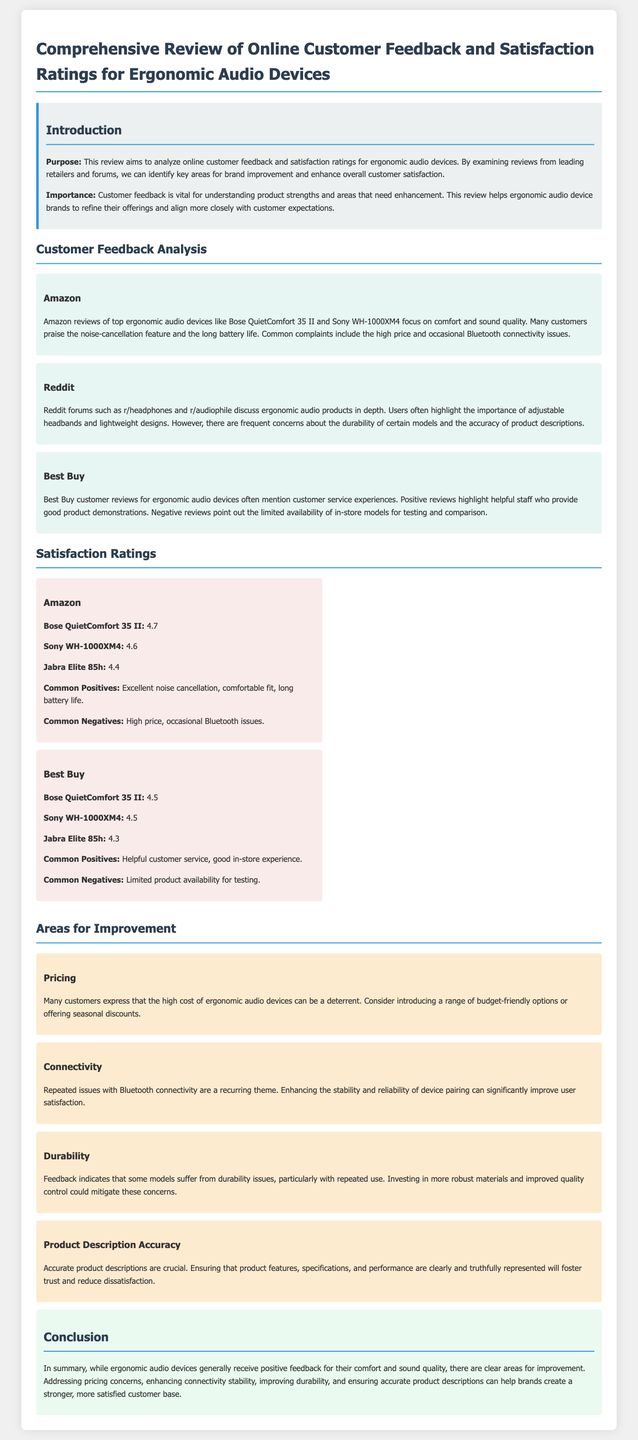What is the purpose of the review? The purpose is to analyze online customer feedback and satisfaction ratings for ergonomic audio devices.
Answer: Analyze online customer feedback and satisfaction ratings What product has the highest rating on Amazon? The product with the highest rating on Amazon is the Bose QuietComfort 35 II, with a rating of 4.7.
Answer: Bose QuietComfort 35 II Which ergonomic audio devices received a 4.5 rating on Best Buy? Both the Bose QuietComfort 35 II and Sony WH-1000XM4 received a rating of 4.5 on Best Buy.
Answer: Bose QuietComfort 35 II and Sony WH-1000XM4 What is a common negative feedback mentioned for ergonomic audio devices on Amazon? The common negative feedback is the high price.
Answer: High price Which area for improvement relates to customer connectivity issues? The area for improvement related to connectivity issues is Bluetooth connectivity.
Answer: Bluetooth connectivity What feature do Reddit users highlight as essential for ergonomic audio products? Users on Reddit highlight the importance of adjustable headbands.
Answer: Adjustable headbands What do positive Best Buy reviews frequently mention? Positive reviews frequently mention helpful customer service.
Answer: Helpful customer service Which ergonomic audio device is discussed in relation to durability concerns? Durability concerns are mentioned regarding certain models, but no specific device is named.
Answer: Certain models 